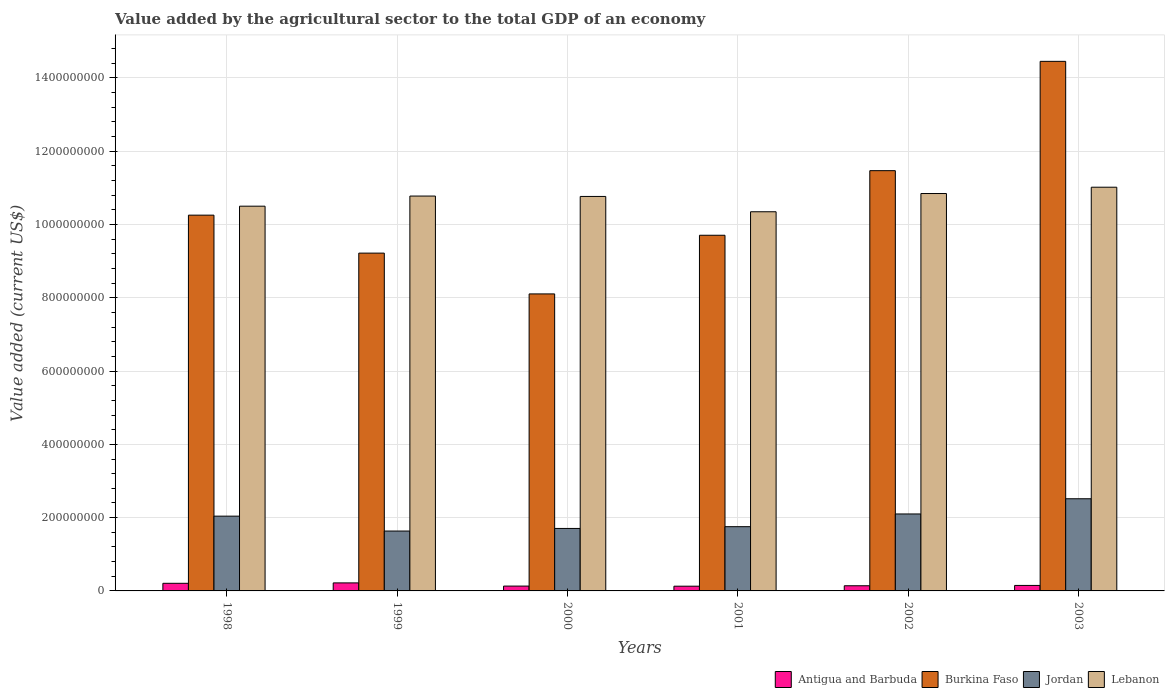How many bars are there on the 5th tick from the left?
Your response must be concise. 4. What is the label of the 6th group of bars from the left?
Provide a short and direct response. 2003. In how many cases, is the number of bars for a given year not equal to the number of legend labels?
Provide a succinct answer. 0. What is the value added by the agricultural sector to the total GDP in Antigua and Barbuda in 2003?
Your answer should be very brief. 1.50e+07. Across all years, what is the maximum value added by the agricultural sector to the total GDP in Antigua and Barbuda?
Make the answer very short. 2.19e+07. Across all years, what is the minimum value added by the agricultural sector to the total GDP in Jordan?
Ensure brevity in your answer.  1.63e+08. In which year was the value added by the agricultural sector to the total GDP in Jordan maximum?
Provide a succinct answer. 2003. What is the total value added by the agricultural sector to the total GDP in Antigua and Barbuda in the graph?
Your response must be concise. 9.78e+07. What is the difference between the value added by the agricultural sector to the total GDP in Jordan in 2001 and that in 2002?
Make the answer very short. -3.47e+07. What is the difference between the value added by the agricultural sector to the total GDP in Lebanon in 2000 and the value added by the agricultural sector to the total GDP in Antigua and Barbuda in 2001?
Offer a very short reply. 1.06e+09. What is the average value added by the agricultural sector to the total GDP in Jordan per year?
Your answer should be compact. 1.96e+08. In the year 2001, what is the difference between the value added by the agricultural sector to the total GDP in Burkina Faso and value added by the agricultural sector to the total GDP in Antigua and Barbuda?
Make the answer very short. 9.58e+08. In how many years, is the value added by the agricultural sector to the total GDP in Lebanon greater than 1120000000 US$?
Your answer should be very brief. 0. What is the ratio of the value added by the agricultural sector to the total GDP in Antigua and Barbuda in 1999 to that in 2001?
Make the answer very short. 1.7. Is the value added by the agricultural sector to the total GDP in Antigua and Barbuda in 2000 less than that in 2002?
Give a very brief answer. Yes. What is the difference between the highest and the second highest value added by the agricultural sector to the total GDP in Lebanon?
Keep it short and to the point. 1.72e+07. What is the difference between the highest and the lowest value added by the agricultural sector to the total GDP in Burkina Faso?
Give a very brief answer. 6.35e+08. In how many years, is the value added by the agricultural sector to the total GDP in Jordan greater than the average value added by the agricultural sector to the total GDP in Jordan taken over all years?
Your response must be concise. 3. Is the sum of the value added by the agricultural sector to the total GDP in Jordan in 1998 and 2000 greater than the maximum value added by the agricultural sector to the total GDP in Burkina Faso across all years?
Your answer should be very brief. No. Is it the case that in every year, the sum of the value added by the agricultural sector to the total GDP in Antigua and Barbuda and value added by the agricultural sector to the total GDP in Lebanon is greater than the sum of value added by the agricultural sector to the total GDP in Burkina Faso and value added by the agricultural sector to the total GDP in Jordan?
Give a very brief answer. Yes. What does the 1st bar from the left in 2001 represents?
Offer a terse response. Antigua and Barbuda. What does the 4th bar from the right in 2003 represents?
Your response must be concise. Antigua and Barbuda. Is it the case that in every year, the sum of the value added by the agricultural sector to the total GDP in Antigua and Barbuda and value added by the agricultural sector to the total GDP in Lebanon is greater than the value added by the agricultural sector to the total GDP in Burkina Faso?
Give a very brief answer. No. How many bars are there?
Keep it short and to the point. 24. Are the values on the major ticks of Y-axis written in scientific E-notation?
Your answer should be very brief. No. Does the graph contain any zero values?
Offer a very short reply. No. Where does the legend appear in the graph?
Your response must be concise. Bottom right. How many legend labels are there?
Make the answer very short. 4. What is the title of the graph?
Provide a short and direct response. Value added by the agricultural sector to the total GDP of an economy. What is the label or title of the Y-axis?
Make the answer very short. Value added (current US$). What is the Value added (current US$) in Antigua and Barbuda in 1998?
Keep it short and to the point. 2.08e+07. What is the Value added (current US$) of Burkina Faso in 1998?
Offer a terse response. 1.03e+09. What is the Value added (current US$) of Jordan in 1998?
Provide a succinct answer. 2.04e+08. What is the Value added (current US$) in Lebanon in 1998?
Offer a terse response. 1.05e+09. What is the Value added (current US$) of Antigua and Barbuda in 1999?
Make the answer very short. 2.19e+07. What is the Value added (current US$) of Burkina Faso in 1999?
Provide a short and direct response. 9.22e+08. What is the Value added (current US$) of Jordan in 1999?
Give a very brief answer. 1.63e+08. What is the Value added (current US$) of Lebanon in 1999?
Give a very brief answer. 1.08e+09. What is the Value added (current US$) of Antigua and Barbuda in 2000?
Your response must be concise. 1.32e+07. What is the Value added (current US$) in Burkina Faso in 2000?
Your response must be concise. 8.11e+08. What is the Value added (current US$) of Jordan in 2000?
Give a very brief answer. 1.71e+08. What is the Value added (current US$) in Lebanon in 2000?
Your answer should be compact. 1.08e+09. What is the Value added (current US$) of Antigua and Barbuda in 2001?
Offer a terse response. 1.29e+07. What is the Value added (current US$) in Burkina Faso in 2001?
Keep it short and to the point. 9.71e+08. What is the Value added (current US$) in Jordan in 2001?
Offer a very short reply. 1.75e+08. What is the Value added (current US$) in Lebanon in 2001?
Offer a very short reply. 1.03e+09. What is the Value added (current US$) in Antigua and Barbuda in 2002?
Your response must be concise. 1.41e+07. What is the Value added (current US$) of Burkina Faso in 2002?
Give a very brief answer. 1.15e+09. What is the Value added (current US$) of Jordan in 2002?
Provide a succinct answer. 2.10e+08. What is the Value added (current US$) of Lebanon in 2002?
Make the answer very short. 1.08e+09. What is the Value added (current US$) in Antigua and Barbuda in 2003?
Provide a short and direct response. 1.50e+07. What is the Value added (current US$) in Burkina Faso in 2003?
Provide a short and direct response. 1.45e+09. What is the Value added (current US$) in Jordan in 2003?
Make the answer very short. 2.52e+08. What is the Value added (current US$) of Lebanon in 2003?
Your answer should be compact. 1.10e+09. Across all years, what is the maximum Value added (current US$) of Antigua and Barbuda?
Make the answer very short. 2.19e+07. Across all years, what is the maximum Value added (current US$) of Burkina Faso?
Ensure brevity in your answer.  1.45e+09. Across all years, what is the maximum Value added (current US$) in Jordan?
Make the answer very short. 2.52e+08. Across all years, what is the maximum Value added (current US$) of Lebanon?
Keep it short and to the point. 1.10e+09. Across all years, what is the minimum Value added (current US$) of Antigua and Barbuda?
Ensure brevity in your answer.  1.29e+07. Across all years, what is the minimum Value added (current US$) of Burkina Faso?
Provide a succinct answer. 8.11e+08. Across all years, what is the minimum Value added (current US$) of Jordan?
Provide a succinct answer. 1.63e+08. Across all years, what is the minimum Value added (current US$) in Lebanon?
Your answer should be compact. 1.03e+09. What is the total Value added (current US$) in Antigua and Barbuda in the graph?
Your answer should be compact. 9.78e+07. What is the total Value added (current US$) in Burkina Faso in the graph?
Ensure brevity in your answer.  6.32e+09. What is the total Value added (current US$) in Jordan in the graph?
Give a very brief answer. 1.17e+09. What is the total Value added (current US$) in Lebanon in the graph?
Your answer should be compact. 6.43e+09. What is the difference between the Value added (current US$) of Antigua and Barbuda in 1998 and that in 1999?
Your answer should be compact. -1.11e+06. What is the difference between the Value added (current US$) of Burkina Faso in 1998 and that in 1999?
Provide a short and direct response. 1.04e+08. What is the difference between the Value added (current US$) in Jordan in 1998 and that in 1999?
Ensure brevity in your answer.  4.06e+07. What is the difference between the Value added (current US$) in Lebanon in 1998 and that in 1999?
Make the answer very short. -2.77e+07. What is the difference between the Value added (current US$) in Antigua and Barbuda in 1998 and that in 2000?
Give a very brief answer. 7.58e+06. What is the difference between the Value added (current US$) of Burkina Faso in 1998 and that in 2000?
Give a very brief answer. 2.15e+08. What is the difference between the Value added (current US$) of Jordan in 1998 and that in 2000?
Your response must be concise. 3.36e+07. What is the difference between the Value added (current US$) in Lebanon in 1998 and that in 2000?
Offer a terse response. -2.66e+07. What is the difference between the Value added (current US$) of Antigua and Barbuda in 1998 and that in 2001?
Offer a very short reply. 7.86e+06. What is the difference between the Value added (current US$) in Burkina Faso in 1998 and that in 2001?
Provide a short and direct response. 5.49e+07. What is the difference between the Value added (current US$) in Jordan in 1998 and that in 2001?
Your answer should be compact. 2.87e+07. What is the difference between the Value added (current US$) in Lebanon in 1998 and that in 2001?
Keep it short and to the point. 1.52e+07. What is the difference between the Value added (current US$) in Antigua and Barbuda in 1998 and that in 2002?
Make the answer very short. 6.68e+06. What is the difference between the Value added (current US$) in Burkina Faso in 1998 and that in 2002?
Give a very brief answer. -1.21e+08. What is the difference between the Value added (current US$) in Jordan in 1998 and that in 2002?
Ensure brevity in your answer.  -5.98e+06. What is the difference between the Value added (current US$) of Lebanon in 1998 and that in 2002?
Your answer should be compact. -3.45e+07. What is the difference between the Value added (current US$) in Antigua and Barbuda in 1998 and that in 2003?
Make the answer very short. 5.81e+06. What is the difference between the Value added (current US$) in Burkina Faso in 1998 and that in 2003?
Provide a succinct answer. -4.20e+08. What is the difference between the Value added (current US$) of Jordan in 1998 and that in 2003?
Ensure brevity in your answer.  -4.74e+07. What is the difference between the Value added (current US$) in Lebanon in 1998 and that in 2003?
Keep it short and to the point. -5.18e+07. What is the difference between the Value added (current US$) of Antigua and Barbuda in 1999 and that in 2000?
Your answer should be very brief. 8.69e+06. What is the difference between the Value added (current US$) of Burkina Faso in 1999 and that in 2000?
Ensure brevity in your answer.  1.11e+08. What is the difference between the Value added (current US$) in Jordan in 1999 and that in 2000?
Offer a terse response. -7.06e+06. What is the difference between the Value added (current US$) of Lebanon in 1999 and that in 2000?
Your response must be concise. 1.08e+06. What is the difference between the Value added (current US$) of Antigua and Barbuda in 1999 and that in 2001?
Offer a very short reply. 8.98e+06. What is the difference between the Value added (current US$) in Burkina Faso in 1999 and that in 2001?
Provide a succinct answer. -4.88e+07. What is the difference between the Value added (current US$) of Jordan in 1999 and that in 2001?
Give a very brief answer. -1.19e+07. What is the difference between the Value added (current US$) of Lebanon in 1999 and that in 2001?
Give a very brief answer. 4.29e+07. What is the difference between the Value added (current US$) in Antigua and Barbuda in 1999 and that in 2002?
Your answer should be compact. 7.79e+06. What is the difference between the Value added (current US$) of Burkina Faso in 1999 and that in 2002?
Your response must be concise. -2.25e+08. What is the difference between the Value added (current US$) of Jordan in 1999 and that in 2002?
Your answer should be compact. -4.66e+07. What is the difference between the Value added (current US$) in Lebanon in 1999 and that in 2002?
Your answer should be very brief. -6.88e+06. What is the difference between the Value added (current US$) of Antigua and Barbuda in 1999 and that in 2003?
Your response must be concise. 6.92e+06. What is the difference between the Value added (current US$) of Burkina Faso in 1999 and that in 2003?
Give a very brief answer. -5.23e+08. What is the difference between the Value added (current US$) of Jordan in 1999 and that in 2003?
Give a very brief answer. -8.81e+07. What is the difference between the Value added (current US$) of Lebanon in 1999 and that in 2003?
Provide a succinct answer. -2.41e+07. What is the difference between the Value added (current US$) of Antigua and Barbuda in 2000 and that in 2001?
Ensure brevity in your answer.  2.82e+05. What is the difference between the Value added (current US$) in Burkina Faso in 2000 and that in 2001?
Your response must be concise. -1.60e+08. What is the difference between the Value added (current US$) in Jordan in 2000 and that in 2001?
Offer a terse response. -4.83e+06. What is the difference between the Value added (current US$) in Lebanon in 2000 and that in 2001?
Ensure brevity in your answer.  4.18e+07. What is the difference between the Value added (current US$) of Antigua and Barbuda in 2000 and that in 2002?
Make the answer very short. -9.00e+05. What is the difference between the Value added (current US$) of Burkina Faso in 2000 and that in 2002?
Give a very brief answer. -3.36e+08. What is the difference between the Value added (current US$) of Jordan in 2000 and that in 2002?
Provide a succinct answer. -3.95e+07. What is the difference between the Value added (current US$) in Lebanon in 2000 and that in 2002?
Your answer should be compact. -7.96e+06. What is the difference between the Value added (current US$) of Antigua and Barbuda in 2000 and that in 2003?
Give a very brief answer. -1.77e+06. What is the difference between the Value added (current US$) of Burkina Faso in 2000 and that in 2003?
Offer a very short reply. -6.35e+08. What is the difference between the Value added (current US$) in Jordan in 2000 and that in 2003?
Ensure brevity in your answer.  -8.10e+07. What is the difference between the Value added (current US$) in Lebanon in 2000 and that in 2003?
Ensure brevity in your answer.  -2.52e+07. What is the difference between the Value added (current US$) of Antigua and Barbuda in 2001 and that in 2002?
Your answer should be very brief. -1.18e+06. What is the difference between the Value added (current US$) of Burkina Faso in 2001 and that in 2002?
Make the answer very short. -1.76e+08. What is the difference between the Value added (current US$) of Jordan in 2001 and that in 2002?
Offer a very short reply. -3.47e+07. What is the difference between the Value added (current US$) of Lebanon in 2001 and that in 2002?
Your answer should be very brief. -4.98e+07. What is the difference between the Value added (current US$) in Antigua and Barbuda in 2001 and that in 2003?
Give a very brief answer. -2.06e+06. What is the difference between the Value added (current US$) in Burkina Faso in 2001 and that in 2003?
Offer a terse response. -4.75e+08. What is the difference between the Value added (current US$) of Jordan in 2001 and that in 2003?
Ensure brevity in your answer.  -7.62e+07. What is the difference between the Value added (current US$) of Lebanon in 2001 and that in 2003?
Ensure brevity in your answer.  -6.70e+07. What is the difference between the Value added (current US$) in Antigua and Barbuda in 2002 and that in 2003?
Your answer should be very brief. -8.74e+05. What is the difference between the Value added (current US$) in Burkina Faso in 2002 and that in 2003?
Ensure brevity in your answer.  -2.98e+08. What is the difference between the Value added (current US$) of Jordan in 2002 and that in 2003?
Provide a short and direct response. -4.15e+07. What is the difference between the Value added (current US$) in Lebanon in 2002 and that in 2003?
Make the answer very short. -1.72e+07. What is the difference between the Value added (current US$) in Antigua and Barbuda in 1998 and the Value added (current US$) in Burkina Faso in 1999?
Ensure brevity in your answer.  -9.01e+08. What is the difference between the Value added (current US$) of Antigua and Barbuda in 1998 and the Value added (current US$) of Jordan in 1999?
Keep it short and to the point. -1.43e+08. What is the difference between the Value added (current US$) of Antigua and Barbuda in 1998 and the Value added (current US$) of Lebanon in 1999?
Offer a very short reply. -1.06e+09. What is the difference between the Value added (current US$) of Burkina Faso in 1998 and the Value added (current US$) of Jordan in 1999?
Offer a very short reply. 8.62e+08. What is the difference between the Value added (current US$) in Burkina Faso in 1998 and the Value added (current US$) in Lebanon in 1999?
Offer a very short reply. -5.21e+07. What is the difference between the Value added (current US$) of Jordan in 1998 and the Value added (current US$) of Lebanon in 1999?
Provide a succinct answer. -8.74e+08. What is the difference between the Value added (current US$) in Antigua and Barbuda in 1998 and the Value added (current US$) in Burkina Faso in 2000?
Offer a very short reply. -7.90e+08. What is the difference between the Value added (current US$) in Antigua and Barbuda in 1998 and the Value added (current US$) in Jordan in 2000?
Keep it short and to the point. -1.50e+08. What is the difference between the Value added (current US$) of Antigua and Barbuda in 1998 and the Value added (current US$) of Lebanon in 2000?
Make the answer very short. -1.06e+09. What is the difference between the Value added (current US$) in Burkina Faso in 1998 and the Value added (current US$) in Jordan in 2000?
Offer a terse response. 8.55e+08. What is the difference between the Value added (current US$) in Burkina Faso in 1998 and the Value added (current US$) in Lebanon in 2000?
Your answer should be very brief. -5.10e+07. What is the difference between the Value added (current US$) in Jordan in 1998 and the Value added (current US$) in Lebanon in 2000?
Offer a very short reply. -8.73e+08. What is the difference between the Value added (current US$) of Antigua and Barbuda in 1998 and the Value added (current US$) of Burkina Faso in 2001?
Provide a short and direct response. -9.50e+08. What is the difference between the Value added (current US$) in Antigua and Barbuda in 1998 and the Value added (current US$) in Jordan in 2001?
Offer a very short reply. -1.55e+08. What is the difference between the Value added (current US$) in Antigua and Barbuda in 1998 and the Value added (current US$) in Lebanon in 2001?
Make the answer very short. -1.01e+09. What is the difference between the Value added (current US$) of Burkina Faso in 1998 and the Value added (current US$) of Jordan in 2001?
Provide a succinct answer. 8.50e+08. What is the difference between the Value added (current US$) in Burkina Faso in 1998 and the Value added (current US$) in Lebanon in 2001?
Offer a very short reply. -9.25e+06. What is the difference between the Value added (current US$) in Jordan in 1998 and the Value added (current US$) in Lebanon in 2001?
Provide a succinct answer. -8.31e+08. What is the difference between the Value added (current US$) in Antigua and Barbuda in 1998 and the Value added (current US$) in Burkina Faso in 2002?
Make the answer very short. -1.13e+09. What is the difference between the Value added (current US$) of Antigua and Barbuda in 1998 and the Value added (current US$) of Jordan in 2002?
Provide a succinct answer. -1.89e+08. What is the difference between the Value added (current US$) in Antigua and Barbuda in 1998 and the Value added (current US$) in Lebanon in 2002?
Your response must be concise. -1.06e+09. What is the difference between the Value added (current US$) of Burkina Faso in 1998 and the Value added (current US$) of Jordan in 2002?
Give a very brief answer. 8.16e+08. What is the difference between the Value added (current US$) of Burkina Faso in 1998 and the Value added (current US$) of Lebanon in 2002?
Give a very brief answer. -5.90e+07. What is the difference between the Value added (current US$) of Jordan in 1998 and the Value added (current US$) of Lebanon in 2002?
Provide a succinct answer. -8.80e+08. What is the difference between the Value added (current US$) of Antigua and Barbuda in 1998 and the Value added (current US$) of Burkina Faso in 2003?
Your answer should be very brief. -1.42e+09. What is the difference between the Value added (current US$) in Antigua and Barbuda in 1998 and the Value added (current US$) in Jordan in 2003?
Your response must be concise. -2.31e+08. What is the difference between the Value added (current US$) of Antigua and Barbuda in 1998 and the Value added (current US$) of Lebanon in 2003?
Your response must be concise. -1.08e+09. What is the difference between the Value added (current US$) of Burkina Faso in 1998 and the Value added (current US$) of Jordan in 2003?
Keep it short and to the point. 7.74e+08. What is the difference between the Value added (current US$) of Burkina Faso in 1998 and the Value added (current US$) of Lebanon in 2003?
Your response must be concise. -7.63e+07. What is the difference between the Value added (current US$) in Jordan in 1998 and the Value added (current US$) in Lebanon in 2003?
Your answer should be compact. -8.98e+08. What is the difference between the Value added (current US$) of Antigua and Barbuda in 1999 and the Value added (current US$) of Burkina Faso in 2000?
Provide a succinct answer. -7.89e+08. What is the difference between the Value added (current US$) in Antigua and Barbuda in 1999 and the Value added (current US$) in Jordan in 2000?
Make the answer very short. -1.49e+08. What is the difference between the Value added (current US$) in Antigua and Barbuda in 1999 and the Value added (current US$) in Lebanon in 2000?
Offer a terse response. -1.05e+09. What is the difference between the Value added (current US$) in Burkina Faso in 1999 and the Value added (current US$) in Jordan in 2000?
Keep it short and to the point. 7.51e+08. What is the difference between the Value added (current US$) in Burkina Faso in 1999 and the Value added (current US$) in Lebanon in 2000?
Provide a short and direct response. -1.55e+08. What is the difference between the Value added (current US$) of Jordan in 1999 and the Value added (current US$) of Lebanon in 2000?
Provide a short and direct response. -9.13e+08. What is the difference between the Value added (current US$) in Antigua and Barbuda in 1999 and the Value added (current US$) in Burkina Faso in 2001?
Make the answer very short. -9.49e+08. What is the difference between the Value added (current US$) of Antigua and Barbuda in 1999 and the Value added (current US$) of Jordan in 2001?
Provide a succinct answer. -1.53e+08. What is the difference between the Value added (current US$) of Antigua and Barbuda in 1999 and the Value added (current US$) of Lebanon in 2001?
Ensure brevity in your answer.  -1.01e+09. What is the difference between the Value added (current US$) in Burkina Faso in 1999 and the Value added (current US$) in Jordan in 2001?
Give a very brief answer. 7.47e+08. What is the difference between the Value added (current US$) in Burkina Faso in 1999 and the Value added (current US$) in Lebanon in 2001?
Your response must be concise. -1.13e+08. What is the difference between the Value added (current US$) of Jordan in 1999 and the Value added (current US$) of Lebanon in 2001?
Your answer should be very brief. -8.71e+08. What is the difference between the Value added (current US$) in Antigua and Barbuda in 1999 and the Value added (current US$) in Burkina Faso in 2002?
Provide a succinct answer. -1.13e+09. What is the difference between the Value added (current US$) of Antigua and Barbuda in 1999 and the Value added (current US$) of Jordan in 2002?
Provide a short and direct response. -1.88e+08. What is the difference between the Value added (current US$) of Antigua and Barbuda in 1999 and the Value added (current US$) of Lebanon in 2002?
Offer a terse response. -1.06e+09. What is the difference between the Value added (current US$) of Burkina Faso in 1999 and the Value added (current US$) of Jordan in 2002?
Offer a terse response. 7.12e+08. What is the difference between the Value added (current US$) of Burkina Faso in 1999 and the Value added (current US$) of Lebanon in 2002?
Give a very brief answer. -1.63e+08. What is the difference between the Value added (current US$) of Jordan in 1999 and the Value added (current US$) of Lebanon in 2002?
Keep it short and to the point. -9.21e+08. What is the difference between the Value added (current US$) in Antigua and Barbuda in 1999 and the Value added (current US$) in Burkina Faso in 2003?
Your answer should be very brief. -1.42e+09. What is the difference between the Value added (current US$) in Antigua and Barbuda in 1999 and the Value added (current US$) in Jordan in 2003?
Your answer should be very brief. -2.30e+08. What is the difference between the Value added (current US$) of Antigua and Barbuda in 1999 and the Value added (current US$) of Lebanon in 2003?
Your response must be concise. -1.08e+09. What is the difference between the Value added (current US$) in Burkina Faso in 1999 and the Value added (current US$) in Jordan in 2003?
Offer a very short reply. 6.70e+08. What is the difference between the Value added (current US$) of Burkina Faso in 1999 and the Value added (current US$) of Lebanon in 2003?
Offer a very short reply. -1.80e+08. What is the difference between the Value added (current US$) of Jordan in 1999 and the Value added (current US$) of Lebanon in 2003?
Ensure brevity in your answer.  -9.38e+08. What is the difference between the Value added (current US$) in Antigua and Barbuda in 2000 and the Value added (current US$) in Burkina Faso in 2001?
Make the answer very short. -9.57e+08. What is the difference between the Value added (current US$) in Antigua and Barbuda in 2000 and the Value added (current US$) in Jordan in 2001?
Provide a succinct answer. -1.62e+08. What is the difference between the Value added (current US$) of Antigua and Barbuda in 2000 and the Value added (current US$) of Lebanon in 2001?
Your answer should be very brief. -1.02e+09. What is the difference between the Value added (current US$) in Burkina Faso in 2000 and the Value added (current US$) in Jordan in 2001?
Your answer should be compact. 6.35e+08. What is the difference between the Value added (current US$) in Burkina Faso in 2000 and the Value added (current US$) in Lebanon in 2001?
Your answer should be very brief. -2.24e+08. What is the difference between the Value added (current US$) of Jordan in 2000 and the Value added (current US$) of Lebanon in 2001?
Ensure brevity in your answer.  -8.64e+08. What is the difference between the Value added (current US$) in Antigua and Barbuda in 2000 and the Value added (current US$) in Burkina Faso in 2002?
Offer a terse response. -1.13e+09. What is the difference between the Value added (current US$) of Antigua and Barbuda in 2000 and the Value added (current US$) of Jordan in 2002?
Provide a short and direct response. -1.97e+08. What is the difference between the Value added (current US$) in Antigua and Barbuda in 2000 and the Value added (current US$) in Lebanon in 2002?
Ensure brevity in your answer.  -1.07e+09. What is the difference between the Value added (current US$) of Burkina Faso in 2000 and the Value added (current US$) of Jordan in 2002?
Provide a short and direct response. 6.01e+08. What is the difference between the Value added (current US$) of Burkina Faso in 2000 and the Value added (current US$) of Lebanon in 2002?
Keep it short and to the point. -2.74e+08. What is the difference between the Value added (current US$) in Jordan in 2000 and the Value added (current US$) in Lebanon in 2002?
Your answer should be very brief. -9.14e+08. What is the difference between the Value added (current US$) of Antigua and Barbuda in 2000 and the Value added (current US$) of Burkina Faso in 2003?
Make the answer very short. -1.43e+09. What is the difference between the Value added (current US$) in Antigua and Barbuda in 2000 and the Value added (current US$) in Jordan in 2003?
Offer a very short reply. -2.38e+08. What is the difference between the Value added (current US$) in Antigua and Barbuda in 2000 and the Value added (current US$) in Lebanon in 2003?
Provide a short and direct response. -1.09e+09. What is the difference between the Value added (current US$) in Burkina Faso in 2000 and the Value added (current US$) in Jordan in 2003?
Make the answer very short. 5.59e+08. What is the difference between the Value added (current US$) in Burkina Faso in 2000 and the Value added (current US$) in Lebanon in 2003?
Keep it short and to the point. -2.91e+08. What is the difference between the Value added (current US$) in Jordan in 2000 and the Value added (current US$) in Lebanon in 2003?
Your answer should be compact. -9.31e+08. What is the difference between the Value added (current US$) in Antigua and Barbuda in 2001 and the Value added (current US$) in Burkina Faso in 2002?
Provide a succinct answer. -1.13e+09. What is the difference between the Value added (current US$) in Antigua and Barbuda in 2001 and the Value added (current US$) in Jordan in 2002?
Keep it short and to the point. -1.97e+08. What is the difference between the Value added (current US$) of Antigua and Barbuda in 2001 and the Value added (current US$) of Lebanon in 2002?
Keep it short and to the point. -1.07e+09. What is the difference between the Value added (current US$) in Burkina Faso in 2001 and the Value added (current US$) in Jordan in 2002?
Give a very brief answer. 7.61e+08. What is the difference between the Value added (current US$) in Burkina Faso in 2001 and the Value added (current US$) in Lebanon in 2002?
Make the answer very short. -1.14e+08. What is the difference between the Value added (current US$) in Jordan in 2001 and the Value added (current US$) in Lebanon in 2002?
Ensure brevity in your answer.  -9.09e+08. What is the difference between the Value added (current US$) in Antigua and Barbuda in 2001 and the Value added (current US$) in Burkina Faso in 2003?
Ensure brevity in your answer.  -1.43e+09. What is the difference between the Value added (current US$) in Antigua and Barbuda in 2001 and the Value added (current US$) in Jordan in 2003?
Offer a terse response. -2.39e+08. What is the difference between the Value added (current US$) in Antigua and Barbuda in 2001 and the Value added (current US$) in Lebanon in 2003?
Ensure brevity in your answer.  -1.09e+09. What is the difference between the Value added (current US$) in Burkina Faso in 2001 and the Value added (current US$) in Jordan in 2003?
Provide a short and direct response. 7.19e+08. What is the difference between the Value added (current US$) in Burkina Faso in 2001 and the Value added (current US$) in Lebanon in 2003?
Make the answer very short. -1.31e+08. What is the difference between the Value added (current US$) of Jordan in 2001 and the Value added (current US$) of Lebanon in 2003?
Offer a terse response. -9.26e+08. What is the difference between the Value added (current US$) of Antigua and Barbuda in 2002 and the Value added (current US$) of Burkina Faso in 2003?
Make the answer very short. -1.43e+09. What is the difference between the Value added (current US$) of Antigua and Barbuda in 2002 and the Value added (current US$) of Jordan in 2003?
Offer a terse response. -2.37e+08. What is the difference between the Value added (current US$) in Antigua and Barbuda in 2002 and the Value added (current US$) in Lebanon in 2003?
Provide a short and direct response. -1.09e+09. What is the difference between the Value added (current US$) of Burkina Faso in 2002 and the Value added (current US$) of Jordan in 2003?
Your answer should be compact. 8.95e+08. What is the difference between the Value added (current US$) in Burkina Faso in 2002 and the Value added (current US$) in Lebanon in 2003?
Make the answer very short. 4.51e+07. What is the difference between the Value added (current US$) in Jordan in 2002 and the Value added (current US$) in Lebanon in 2003?
Your answer should be compact. -8.92e+08. What is the average Value added (current US$) in Antigua and Barbuda per year?
Ensure brevity in your answer.  1.63e+07. What is the average Value added (current US$) of Burkina Faso per year?
Your response must be concise. 1.05e+09. What is the average Value added (current US$) of Jordan per year?
Provide a short and direct response. 1.96e+08. What is the average Value added (current US$) in Lebanon per year?
Make the answer very short. 1.07e+09. In the year 1998, what is the difference between the Value added (current US$) in Antigua and Barbuda and Value added (current US$) in Burkina Faso?
Your answer should be very brief. -1.00e+09. In the year 1998, what is the difference between the Value added (current US$) of Antigua and Barbuda and Value added (current US$) of Jordan?
Offer a very short reply. -1.83e+08. In the year 1998, what is the difference between the Value added (current US$) of Antigua and Barbuda and Value added (current US$) of Lebanon?
Your answer should be compact. -1.03e+09. In the year 1998, what is the difference between the Value added (current US$) of Burkina Faso and Value added (current US$) of Jordan?
Your answer should be very brief. 8.21e+08. In the year 1998, what is the difference between the Value added (current US$) of Burkina Faso and Value added (current US$) of Lebanon?
Ensure brevity in your answer.  -2.45e+07. In the year 1998, what is the difference between the Value added (current US$) in Jordan and Value added (current US$) in Lebanon?
Make the answer very short. -8.46e+08. In the year 1999, what is the difference between the Value added (current US$) in Antigua and Barbuda and Value added (current US$) in Burkina Faso?
Your answer should be compact. -9.00e+08. In the year 1999, what is the difference between the Value added (current US$) of Antigua and Barbuda and Value added (current US$) of Jordan?
Your answer should be very brief. -1.42e+08. In the year 1999, what is the difference between the Value added (current US$) in Antigua and Barbuda and Value added (current US$) in Lebanon?
Your response must be concise. -1.06e+09. In the year 1999, what is the difference between the Value added (current US$) in Burkina Faso and Value added (current US$) in Jordan?
Provide a short and direct response. 7.58e+08. In the year 1999, what is the difference between the Value added (current US$) in Burkina Faso and Value added (current US$) in Lebanon?
Provide a succinct answer. -1.56e+08. In the year 1999, what is the difference between the Value added (current US$) in Jordan and Value added (current US$) in Lebanon?
Give a very brief answer. -9.14e+08. In the year 2000, what is the difference between the Value added (current US$) in Antigua and Barbuda and Value added (current US$) in Burkina Faso?
Your response must be concise. -7.97e+08. In the year 2000, what is the difference between the Value added (current US$) of Antigua and Barbuda and Value added (current US$) of Jordan?
Make the answer very short. -1.57e+08. In the year 2000, what is the difference between the Value added (current US$) of Antigua and Barbuda and Value added (current US$) of Lebanon?
Give a very brief answer. -1.06e+09. In the year 2000, what is the difference between the Value added (current US$) of Burkina Faso and Value added (current US$) of Jordan?
Your response must be concise. 6.40e+08. In the year 2000, what is the difference between the Value added (current US$) of Burkina Faso and Value added (current US$) of Lebanon?
Provide a succinct answer. -2.66e+08. In the year 2000, what is the difference between the Value added (current US$) of Jordan and Value added (current US$) of Lebanon?
Your answer should be compact. -9.06e+08. In the year 2001, what is the difference between the Value added (current US$) of Antigua and Barbuda and Value added (current US$) of Burkina Faso?
Provide a short and direct response. -9.58e+08. In the year 2001, what is the difference between the Value added (current US$) of Antigua and Barbuda and Value added (current US$) of Jordan?
Your response must be concise. -1.62e+08. In the year 2001, what is the difference between the Value added (current US$) of Antigua and Barbuda and Value added (current US$) of Lebanon?
Give a very brief answer. -1.02e+09. In the year 2001, what is the difference between the Value added (current US$) in Burkina Faso and Value added (current US$) in Jordan?
Your answer should be compact. 7.95e+08. In the year 2001, what is the difference between the Value added (current US$) of Burkina Faso and Value added (current US$) of Lebanon?
Your answer should be compact. -6.41e+07. In the year 2001, what is the difference between the Value added (current US$) in Jordan and Value added (current US$) in Lebanon?
Give a very brief answer. -8.59e+08. In the year 2002, what is the difference between the Value added (current US$) of Antigua and Barbuda and Value added (current US$) of Burkina Faso?
Make the answer very short. -1.13e+09. In the year 2002, what is the difference between the Value added (current US$) in Antigua and Barbuda and Value added (current US$) in Jordan?
Give a very brief answer. -1.96e+08. In the year 2002, what is the difference between the Value added (current US$) in Antigua and Barbuda and Value added (current US$) in Lebanon?
Provide a succinct answer. -1.07e+09. In the year 2002, what is the difference between the Value added (current US$) of Burkina Faso and Value added (current US$) of Jordan?
Your response must be concise. 9.37e+08. In the year 2002, what is the difference between the Value added (current US$) of Burkina Faso and Value added (current US$) of Lebanon?
Provide a succinct answer. 6.24e+07. In the year 2002, what is the difference between the Value added (current US$) in Jordan and Value added (current US$) in Lebanon?
Offer a very short reply. -8.75e+08. In the year 2003, what is the difference between the Value added (current US$) of Antigua and Barbuda and Value added (current US$) of Burkina Faso?
Give a very brief answer. -1.43e+09. In the year 2003, what is the difference between the Value added (current US$) of Antigua and Barbuda and Value added (current US$) of Jordan?
Your answer should be very brief. -2.37e+08. In the year 2003, what is the difference between the Value added (current US$) of Antigua and Barbuda and Value added (current US$) of Lebanon?
Offer a terse response. -1.09e+09. In the year 2003, what is the difference between the Value added (current US$) of Burkina Faso and Value added (current US$) of Jordan?
Your answer should be very brief. 1.19e+09. In the year 2003, what is the difference between the Value added (current US$) of Burkina Faso and Value added (current US$) of Lebanon?
Provide a succinct answer. 3.43e+08. In the year 2003, what is the difference between the Value added (current US$) in Jordan and Value added (current US$) in Lebanon?
Provide a succinct answer. -8.50e+08. What is the ratio of the Value added (current US$) in Antigua and Barbuda in 1998 to that in 1999?
Provide a short and direct response. 0.95. What is the ratio of the Value added (current US$) in Burkina Faso in 1998 to that in 1999?
Provide a succinct answer. 1.11. What is the ratio of the Value added (current US$) in Jordan in 1998 to that in 1999?
Give a very brief answer. 1.25. What is the ratio of the Value added (current US$) in Lebanon in 1998 to that in 1999?
Provide a succinct answer. 0.97. What is the ratio of the Value added (current US$) in Antigua and Barbuda in 1998 to that in 2000?
Your response must be concise. 1.57. What is the ratio of the Value added (current US$) of Burkina Faso in 1998 to that in 2000?
Make the answer very short. 1.27. What is the ratio of the Value added (current US$) in Jordan in 1998 to that in 2000?
Provide a short and direct response. 1.2. What is the ratio of the Value added (current US$) in Lebanon in 1998 to that in 2000?
Your answer should be compact. 0.98. What is the ratio of the Value added (current US$) of Antigua and Barbuda in 1998 to that in 2001?
Provide a succinct answer. 1.61. What is the ratio of the Value added (current US$) of Burkina Faso in 1998 to that in 2001?
Keep it short and to the point. 1.06. What is the ratio of the Value added (current US$) in Jordan in 1998 to that in 2001?
Your answer should be compact. 1.16. What is the ratio of the Value added (current US$) of Lebanon in 1998 to that in 2001?
Your answer should be compact. 1.01. What is the ratio of the Value added (current US$) in Antigua and Barbuda in 1998 to that in 2002?
Your answer should be compact. 1.47. What is the ratio of the Value added (current US$) of Burkina Faso in 1998 to that in 2002?
Ensure brevity in your answer.  0.89. What is the ratio of the Value added (current US$) of Jordan in 1998 to that in 2002?
Your answer should be compact. 0.97. What is the ratio of the Value added (current US$) in Lebanon in 1998 to that in 2002?
Provide a succinct answer. 0.97. What is the ratio of the Value added (current US$) of Antigua and Barbuda in 1998 to that in 2003?
Offer a very short reply. 1.39. What is the ratio of the Value added (current US$) in Burkina Faso in 1998 to that in 2003?
Ensure brevity in your answer.  0.71. What is the ratio of the Value added (current US$) of Jordan in 1998 to that in 2003?
Provide a succinct answer. 0.81. What is the ratio of the Value added (current US$) in Lebanon in 1998 to that in 2003?
Keep it short and to the point. 0.95. What is the ratio of the Value added (current US$) in Antigua and Barbuda in 1999 to that in 2000?
Make the answer very short. 1.66. What is the ratio of the Value added (current US$) of Burkina Faso in 1999 to that in 2000?
Make the answer very short. 1.14. What is the ratio of the Value added (current US$) in Jordan in 1999 to that in 2000?
Offer a very short reply. 0.96. What is the ratio of the Value added (current US$) in Lebanon in 1999 to that in 2000?
Your response must be concise. 1. What is the ratio of the Value added (current US$) in Antigua and Barbuda in 1999 to that in 2001?
Your answer should be compact. 1.7. What is the ratio of the Value added (current US$) in Burkina Faso in 1999 to that in 2001?
Offer a very short reply. 0.95. What is the ratio of the Value added (current US$) in Jordan in 1999 to that in 2001?
Provide a short and direct response. 0.93. What is the ratio of the Value added (current US$) of Lebanon in 1999 to that in 2001?
Offer a very short reply. 1.04. What is the ratio of the Value added (current US$) in Antigua and Barbuda in 1999 to that in 2002?
Offer a terse response. 1.55. What is the ratio of the Value added (current US$) in Burkina Faso in 1999 to that in 2002?
Your answer should be very brief. 0.8. What is the ratio of the Value added (current US$) in Jordan in 1999 to that in 2002?
Provide a succinct answer. 0.78. What is the ratio of the Value added (current US$) in Antigua and Barbuda in 1999 to that in 2003?
Keep it short and to the point. 1.46. What is the ratio of the Value added (current US$) of Burkina Faso in 1999 to that in 2003?
Offer a terse response. 0.64. What is the ratio of the Value added (current US$) of Jordan in 1999 to that in 2003?
Your response must be concise. 0.65. What is the ratio of the Value added (current US$) in Lebanon in 1999 to that in 2003?
Your answer should be compact. 0.98. What is the ratio of the Value added (current US$) of Antigua and Barbuda in 2000 to that in 2001?
Keep it short and to the point. 1.02. What is the ratio of the Value added (current US$) of Burkina Faso in 2000 to that in 2001?
Offer a terse response. 0.84. What is the ratio of the Value added (current US$) of Jordan in 2000 to that in 2001?
Your response must be concise. 0.97. What is the ratio of the Value added (current US$) of Lebanon in 2000 to that in 2001?
Keep it short and to the point. 1.04. What is the ratio of the Value added (current US$) in Antigua and Barbuda in 2000 to that in 2002?
Your answer should be compact. 0.94. What is the ratio of the Value added (current US$) of Burkina Faso in 2000 to that in 2002?
Give a very brief answer. 0.71. What is the ratio of the Value added (current US$) of Jordan in 2000 to that in 2002?
Offer a very short reply. 0.81. What is the ratio of the Value added (current US$) in Lebanon in 2000 to that in 2002?
Offer a very short reply. 0.99. What is the ratio of the Value added (current US$) of Antigua and Barbuda in 2000 to that in 2003?
Your response must be concise. 0.88. What is the ratio of the Value added (current US$) of Burkina Faso in 2000 to that in 2003?
Your answer should be very brief. 0.56. What is the ratio of the Value added (current US$) of Jordan in 2000 to that in 2003?
Your response must be concise. 0.68. What is the ratio of the Value added (current US$) of Lebanon in 2000 to that in 2003?
Provide a succinct answer. 0.98. What is the ratio of the Value added (current US$) of Antigua and Barbuda in 2001 to that in 2002?
Your answer should be very brief. 0.92. What is the ratio of the Value added (current US$) in Burkina Faso in 2001 to that in 2002?
Your answer should be very brief. 0.85. What is the ratio of the Value added (current US$) in Jordan in 2001 to that in 2002?
Your answer should be very brief. 0.83. What is the ratio of the Value added (current US$) in Lebanon in 2001 to that in 2002?
Make the answer very short. 0.95. What is the ratio of the Value added (current US$) in Antigua and Barbuda in 2001 to that in 2003?
Keep it short and to the point. 0.86. What is the ratio of the Value added (current US$) in Burkina Faso in 2001 to that in 2003?
Your answer should be very brief. 0.67. What is the ratio of the Value added (current US$) in Jordan in 2001 to that in 2003?
Provide a succinct answer. 0.7. What is the ratio of the Value added (current US$) in Lebanon in 2001 to that in 2003?
Offer a terse response. 0.94. What is the ratio of the Value added (current US$) in Antigua and Barbuda in 2002 to that in 2003?
Provide a short and direct response. 0.94. What is the ratio of the Value added (current US$) of Burkina Faso in 2002 to that in 2003?
Offer a terse response. 0.79. What is the ratio of the Value added (current US$) of Jordan in 2002 to that in 2003?
Provide a short and direct response. 0.84. What is the ratio of the Value added (current US$) in Lebanon in 2002 to that in 2003?
Give a very brief answer. 0.98. What is the difference between the highest and the second highest Value added (current US$) in Antigua and Barbuda?
Offer a terse response. 1.11e+06. What is the difference between the highest and the second highest Value added (current US$) in Burkina Faso?
Ensure brevity in your answer.  2.98e+08. What is the difference between the highest and the second highest Value added (current US$) of Jordan?
Give a very brief answer. 4.15e+07. What is the difference between the highest and the second highest Value added (current US$) of Lebanon?
Your answer should be very brief. 1.72e+07. What is the difference between the highest and the lowest Value added (current US$) of Antigua and Barbuda?
Give a very brief answer. 8.98e+06. What is the difference between the highest and the lowest Value added (current US$) in Burkina Faso?
Your response must be concise. 6.35e+08. What is the difference between the highest and the lowest Value added (current US$) of Jordan?
Your answer should be very brief. 8.81e+07. What is the difference between the highest and the lowest Value added (current US$) of Lebanon?
Your answer should be very brief. 6.70e+07. 